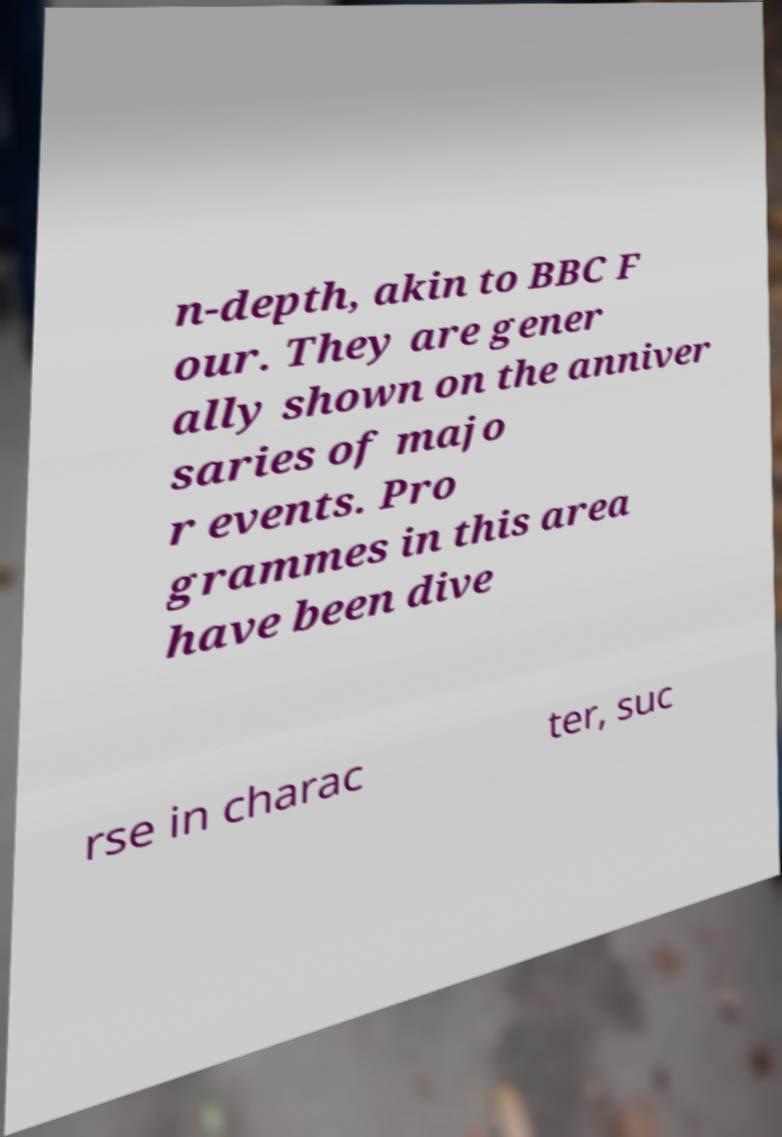Could you extract and type out the text from this image? n-depth, akin to BBC F our. They are gener ally shown on the anniver saries of majo r events. Pro grammes in this area have been dive rse in charac ter, suc 